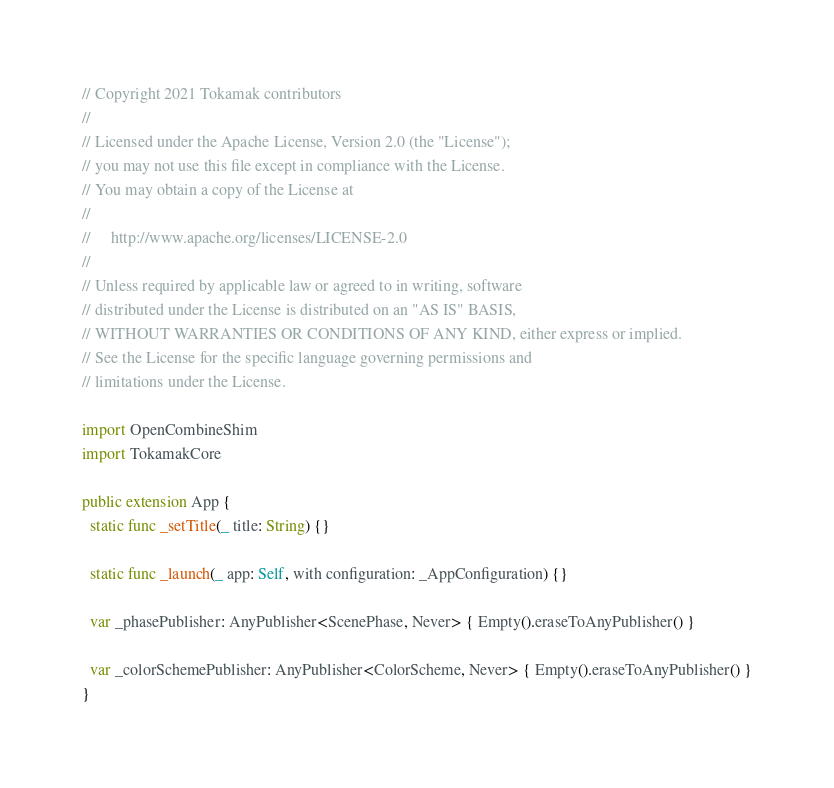<code> <loc_0><loc_0><loc_500><loc_500><_Swift_>// Copyright 2021 Tokamak contributors
//
// Licensed under the Apache License, Version 2.0 (the "License");
// you may not use this file except in compliance with the License.
// You may obtain a copy of the License at
//
//     http://www.apache.org/licenses/LICENSE-2.0
//
// Unless required by applicable law or agreed to in writing, software
// distributed under the License is distributed on an "AS IS" BASIS,
// WITHOUT WARRANTIES OR CONDITIONS OF ANY KIND, either express or implied.
// See the License for the specific language governing permissions and
// limitations under the License.

import OpenCombineShim
import TokamakCore

public extension App {
  static func _setTitle(_ title: String) {}

  static func _launch(_ app: Self, with configuration: _AppConfiguration) {}

  var _phasePublisher: AnyPublisher<ScenePhase, Never> { Empty().eraseToAnyPublisher() }

  var _colorSchemePublisher: AnyPublisher<ColorScheme, Never> { Empty().eraseToAnyPublisher() }
}
</code> 